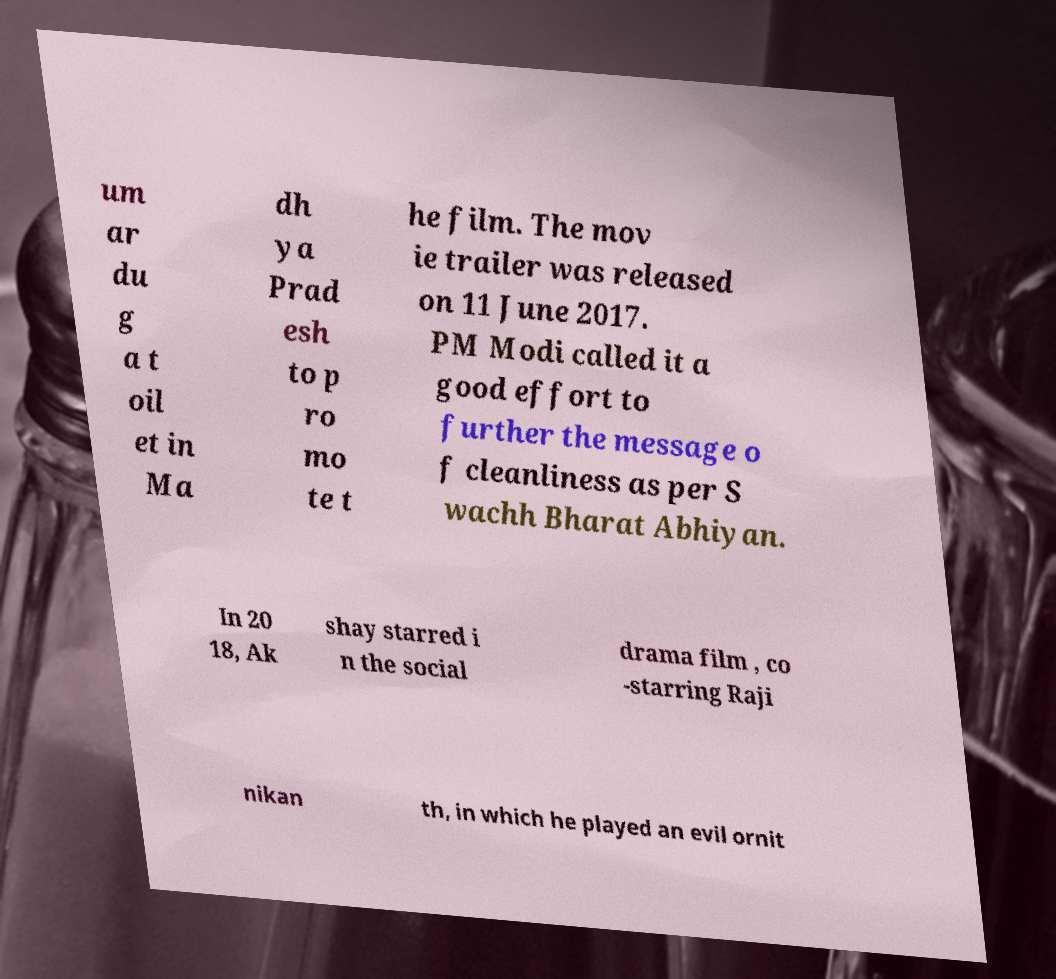Can you read and provide the text displayed in the image?This photo seems to have some interesting text. Can you extract and type it out for me? um ar du g a t oil et in Ma dh ya Prad esh to p ro mo te t he film. The mov ie trailer was released on 11 June 2017. PM Modi called it a good effort to further the message o f cleanliness as per S wachh Bharat Abhiyan. In 20 18, Ak shay starred i n the social drama film , co -starring Raji nikan th, in which he played an evil ornit 